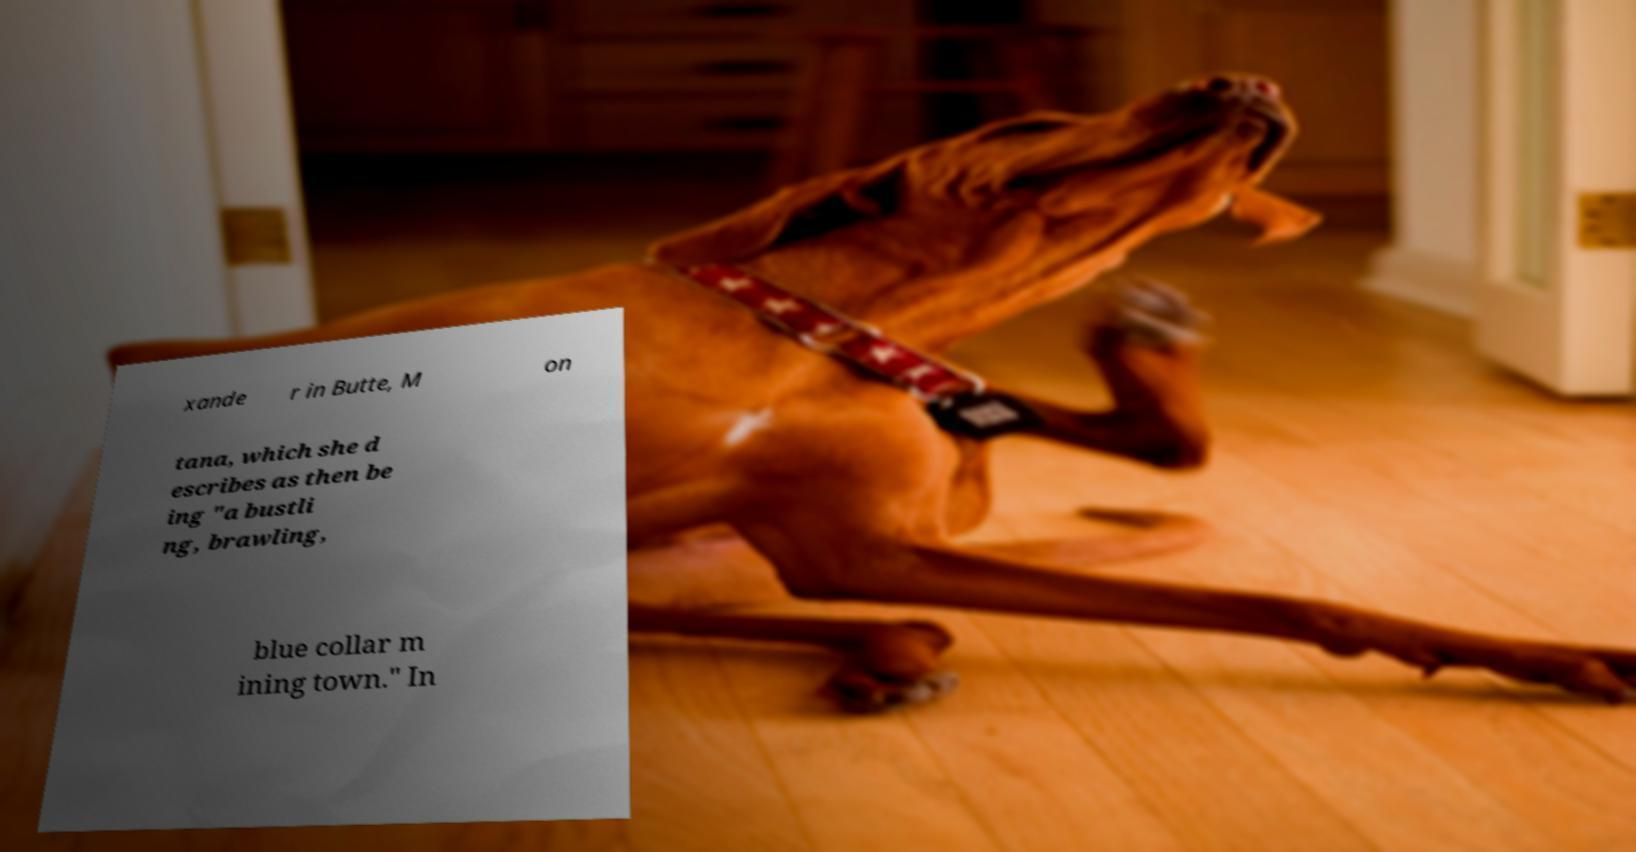For documentation purposes, I need the text within this image transcribed. Could you provide that? xande r in Butte, M on tana, which she d escribes as then be ing "a bustli ng, brawling, blue collar m ining town." In 